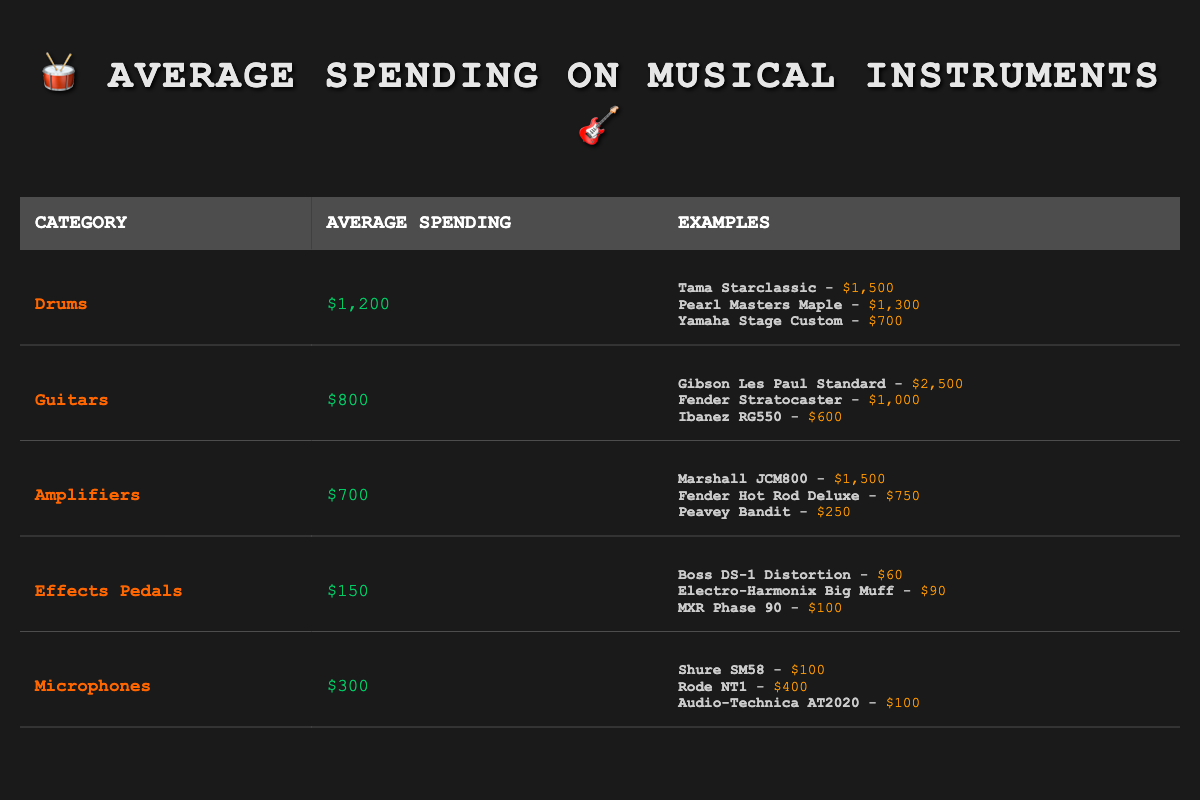What is the average spending on drums? The average spending on drums is listed directly in the table under the "Average Spending" column. It is set at $1,200.
Answer: $1,200 Which category has the highest average spending? Comparing the average spending across all categories, drums have the highest average spending at $1,200.
Answer: Drums What is the price of the least expensive guitar? The least expensive guitar listed is the Ibanez RG550, which costs $600.
Answer: $600 How much more on average do musicians spend on guitars compared to effects pedals? The average spending on guitars is $800 and on effects pedals is $150. The difference is calculated as $800 - $150 = $650.
Answer: $650 Is the average spending on microphones greater than the average spending on effects pedals? The average spending on microphones is $300, while for effects pedals it is $150. Since $300 is greater than $150, the statement is true.
Answer: Yes What would be the total spending if a musician decided to purchase one piece of equipment from each category? To find the total, sum the average spending: $1,200 (drums) + $800 (guitars) + $700 (amplifiers) + $150 (effects pedals) + $300 (microphones) = $3,150.
Answer: $3,150 Which brand of amplifier is the most expensive? From the examples under amplifiers, the Marshall JCM800 is the most expensive at $1,500.
Answer: Marshall JCM800 On average, how much do local musicians spend on amplifiers compared to microphones? The average spending on amplifiers is $700, while on microphones it is $300. The difference is $700 - $300 = $400.
Answer: $400 What is the total cost of the most expensive drum and the least expensive microphone? The most expensive drum is the Tama Starclassic at $1,500, and the least expensive microphone is the Shure SM58 at $100. The total cost is $1,500 + $100 = $1,600.
Answer: $1,600 